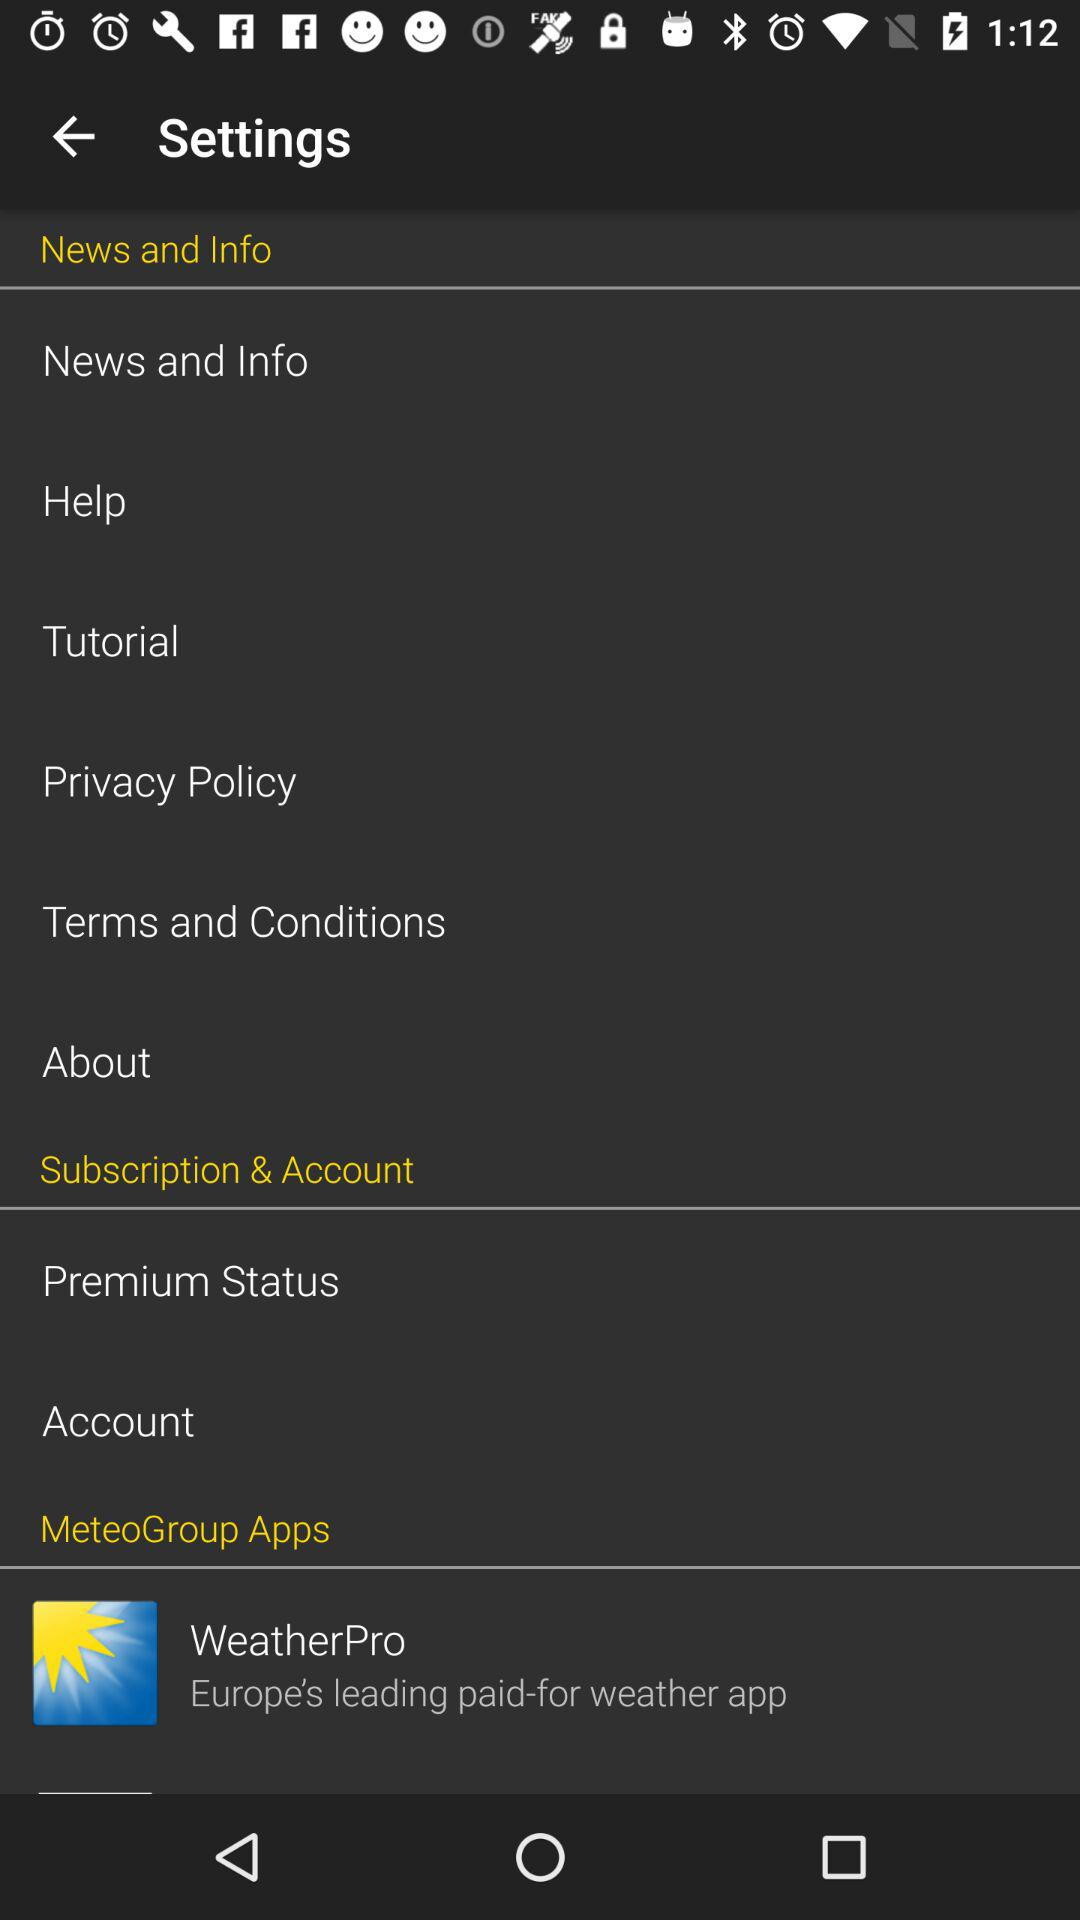Which country is charged for the application?
When the provided information is insufficient, respond with <no answer>. <no answer> 